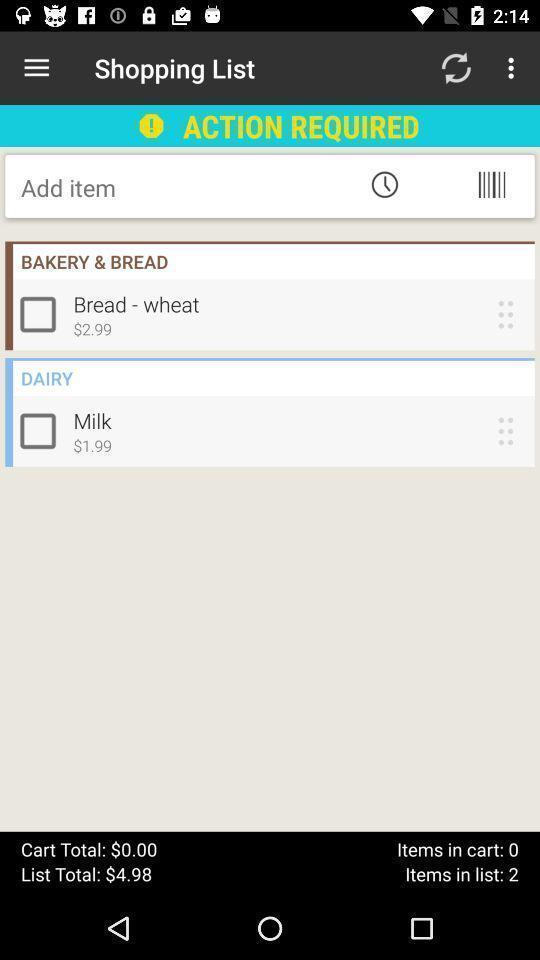What is the overall content of this screenshot? Page showing shopping list with add items. 